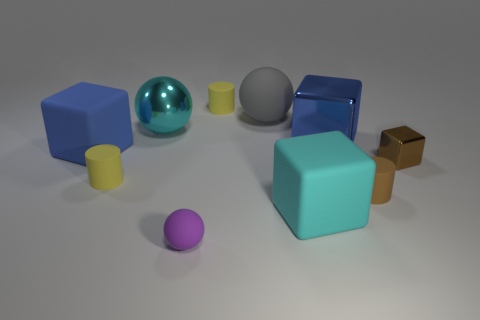What is the size of the cylinder that is the same color as the small metal cube?
Give a very brief answer. Small. There is a tiny thing on the left side of the metallic ball; is its color the same as the large matte thing that is in front of the brown metal cube?
Your answer should be compact. No. What number of other objects are there of the same shape as the big blue matte object?
Provide a short and direct response. 3. Is there a blue rubber cube?
Give a very brief answer. Yes. What number of objects are either matte balls or yellow rubber things that are behind the gray object?
Provide a short and direct response. 3. There is a shiny object left of the cyan block; is its size the same as the big cyan matte thing?
Your answer should be compact. Yes. How many other things are the same size as the brown shiny thing?
Provide a short and direct response. 4. The large rubber sphere has what color?
Offer a terse response. Gray. There is a tiny block on the right side of the big metal cube; what is it made of?
Give a very brief answer. Metal. Is the number of small brown matte objects that are in front of the small brown matte object the same as the number of brown metallic things?
Ensure brevity in your answer.  No. 